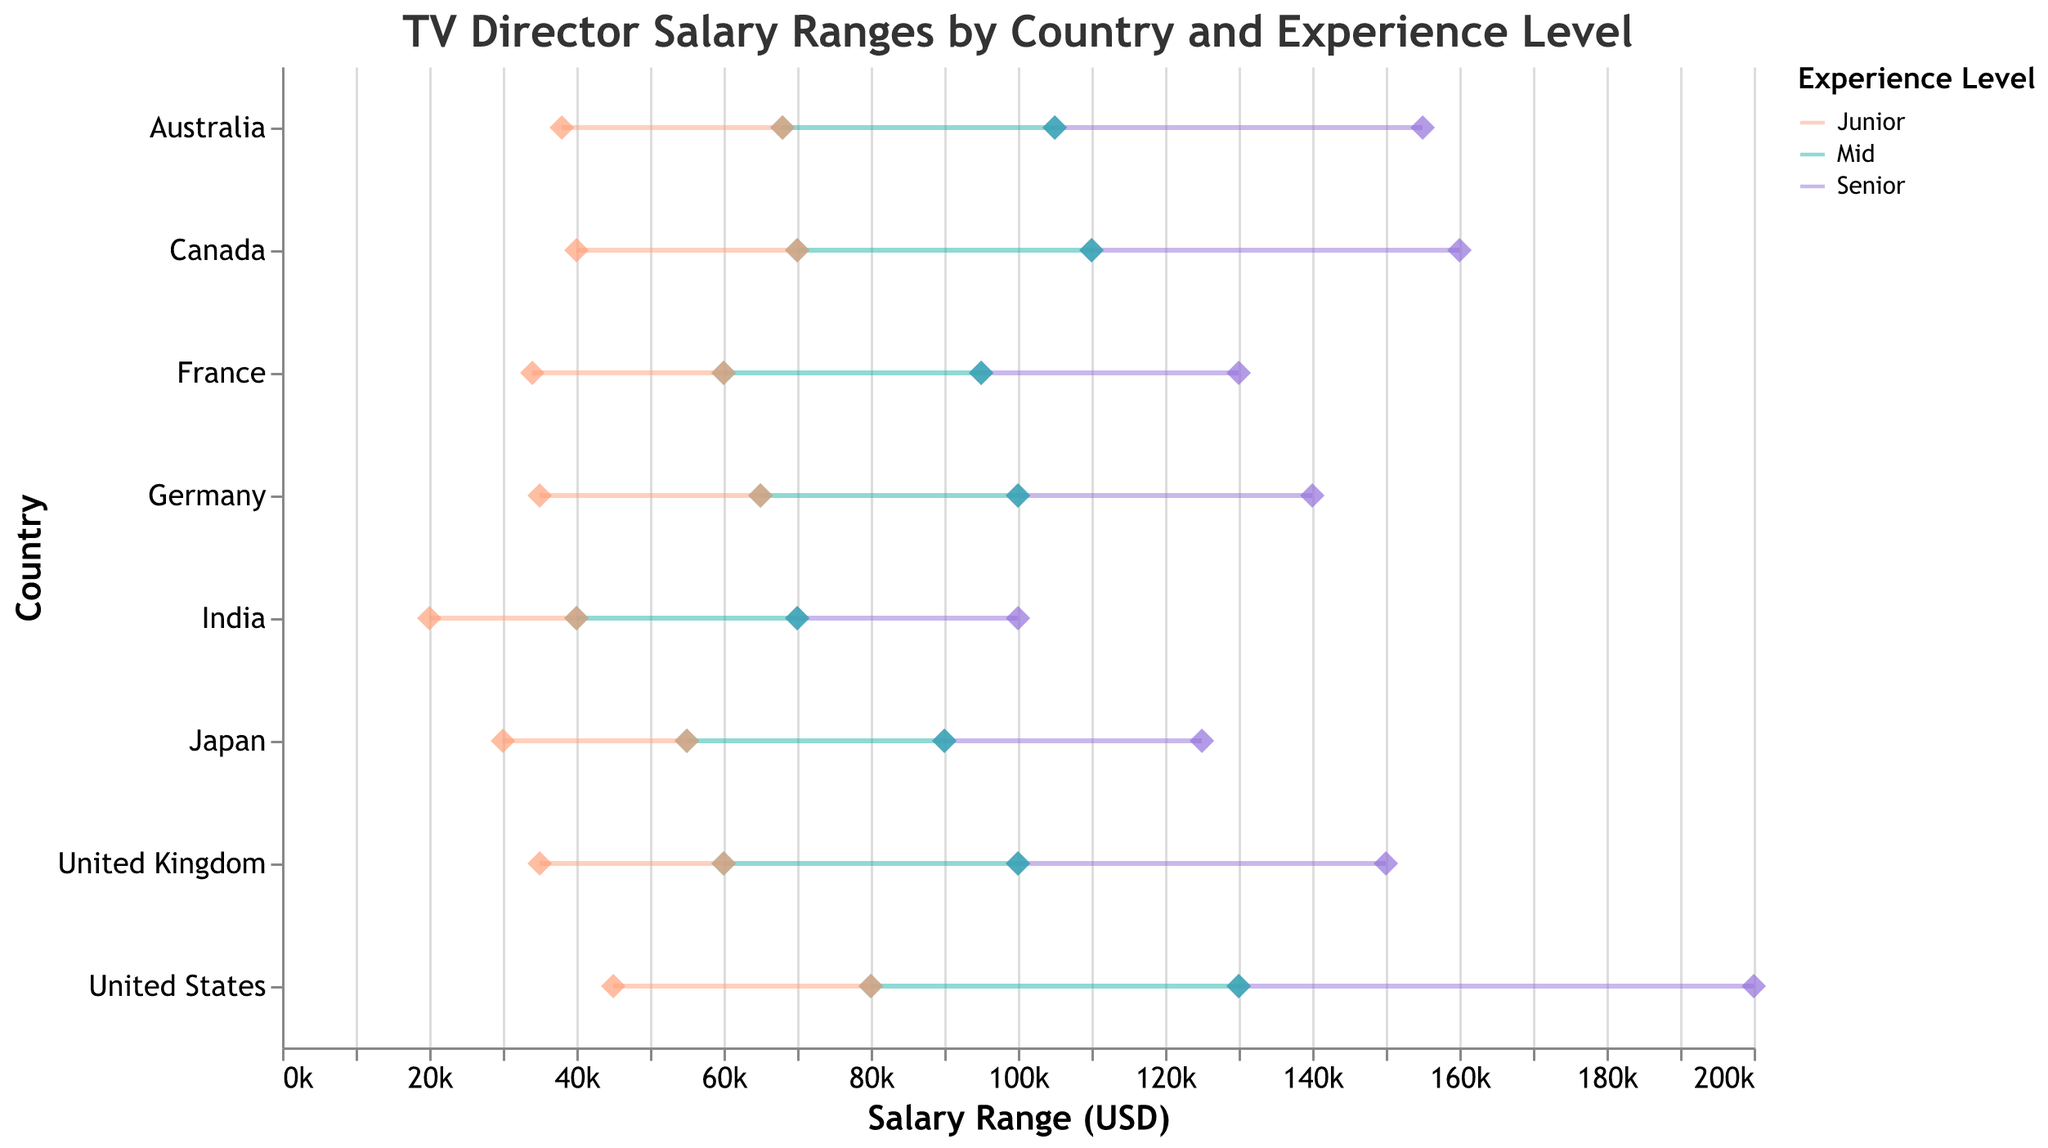How many countries are displayed in the figure? Count the number of unique countries listed on the y-axis.
Answer: 8 What is the maximum salary range for senior-level directors in the United States? Locate the senior-level range for the United States and identify the maximum salary value.
Answer: 200,000 USD Which country offers the highest minimum salary for junior-level TV directors? Compare the minimum salary values for junior-level directors across all countries. The highest value belongs to the United States.
Answer: United States What is the total range of salaries for mid-level directors in Canada? Calculate the difference between the maximum and minimum salaries for mid-level directors in Canada: 110,000 - 70,000 = 40,000 USD.
Answer: 40,000 USD Comparing senior-level salaries, which country has the narrowest range? Subtract the minimum salary from the maximum salary for senior-level roles in each country. Compare the ranges to find the smallest one.
Answer: Germany Which experience level has the widest salary range across all countries? For each experience level, find the range by subtracting the minimum salary from the maximum salary for each country. Compare these values to determine which range is widest.
Answer: Senior How does the salary range for senior directors in Japan compare to that in France? Identify the salary ranges for senior directors in both Japan (90,000 to 125,000 USD) and France (95,000 to 130,000 USD).
Answer: Japan: 90,000 - 125,000 USD, France: 95,000 - 130,000 USD What is the median maximum salary for mid-level directors across all countries? List the maximum salaries for mid-level directors in ascending order: 70,000, 90,000, 95,000, 100,000, 105,000, 110,000, 130,000. The median is the middle value: 100,000 USD.
Answer: 100,000 USD Which country has the lowest maximum salary for junior directors? Identify the maximum salary for junior directors in each country and find the lowest value.
Answer: India By how much does the maximum salary of senior TV directors in Australia exceed that of junior TV directors in Germany? Subtract the maximum salary for junior TV directors in Germany from that of senior TV directors in Australia: 155,000 - 65,000 = 90,000 USD.
Answer: 90,000 USD 